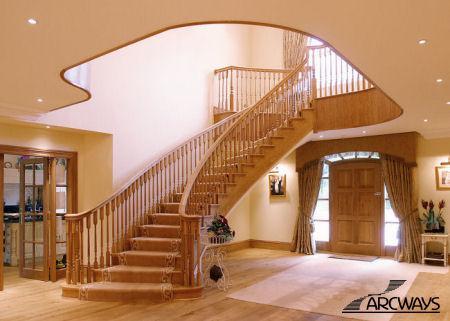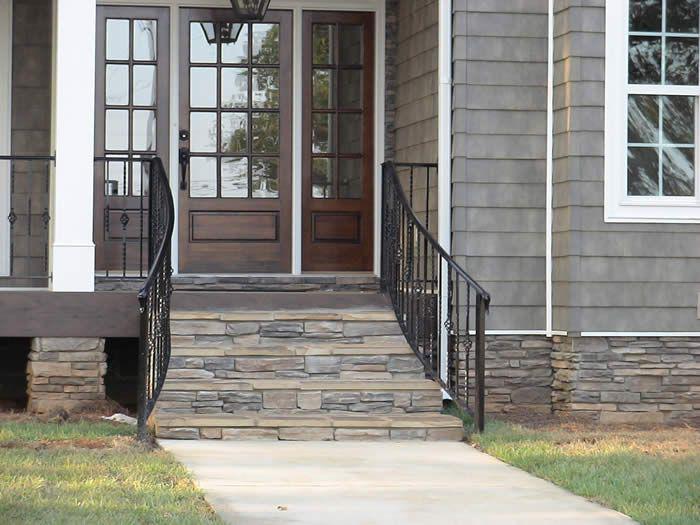The first image is the image on the left, the second image is the image on the right. Assess this claim about the two images: "The exterior of a house is shown with stairs that have very dark-colored railings.". Correct or not? Answer yes or no. Yes. 